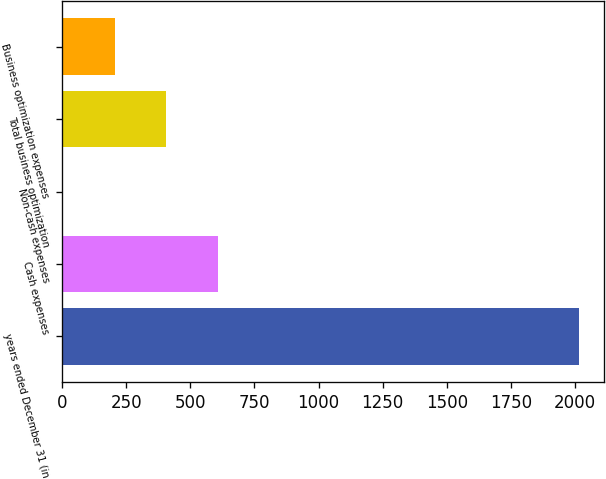<chart> <loc_0><loc_0><loc_500><loc_500><bar_chart><fcel>years ended December 31 (in<fcel>Cash expenses<fcel>Non-cash expenses<fcel>Total business optimization<fcel>Business optimization expenses<nl><fcel>2014<fcel>607<fcel>4<fcel>406<fcel>205<nl></chart> 